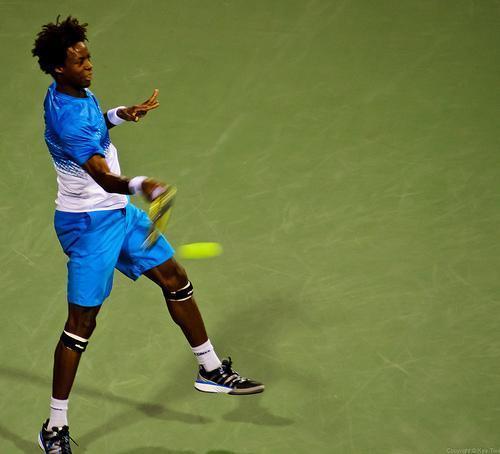How many people are there?
Give a very brief answer. 1. 